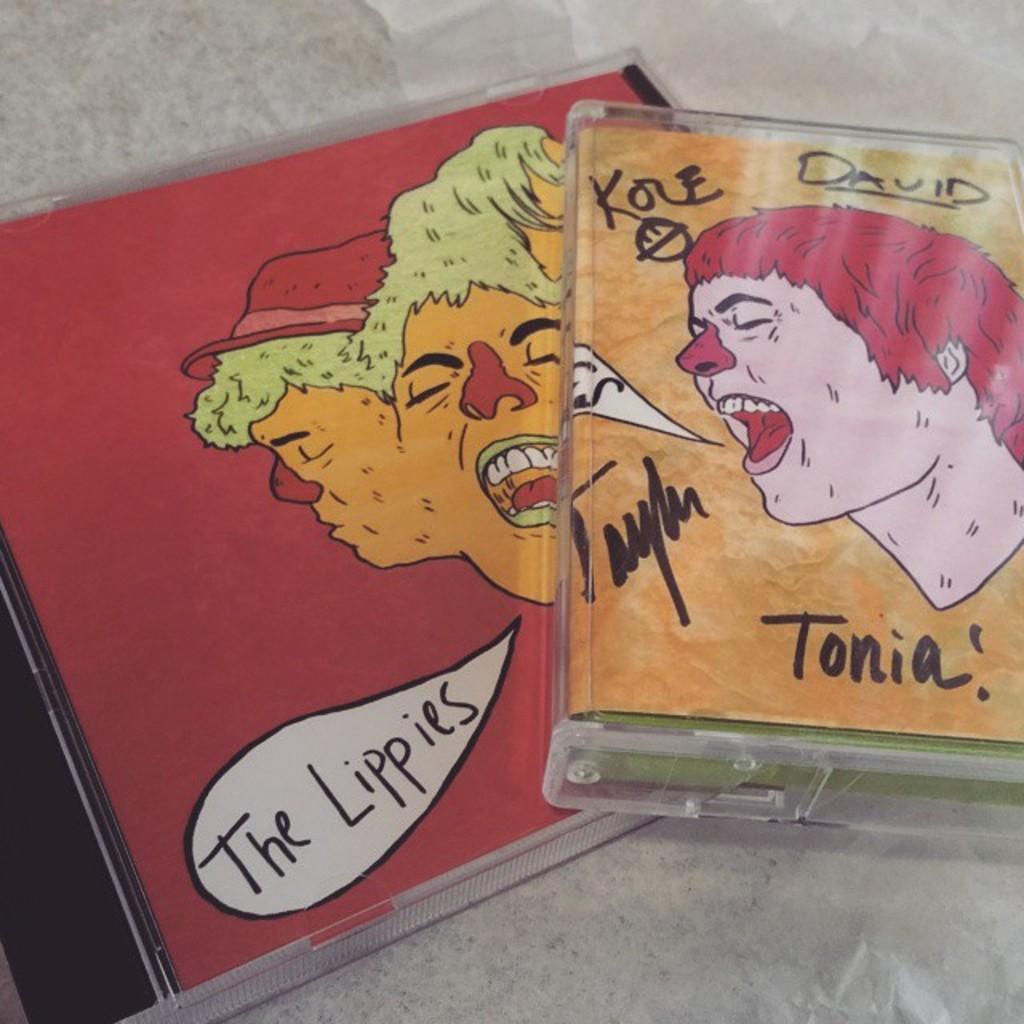How would you summarize this image in a sentence or two? We can see two cassettes on a platform. 